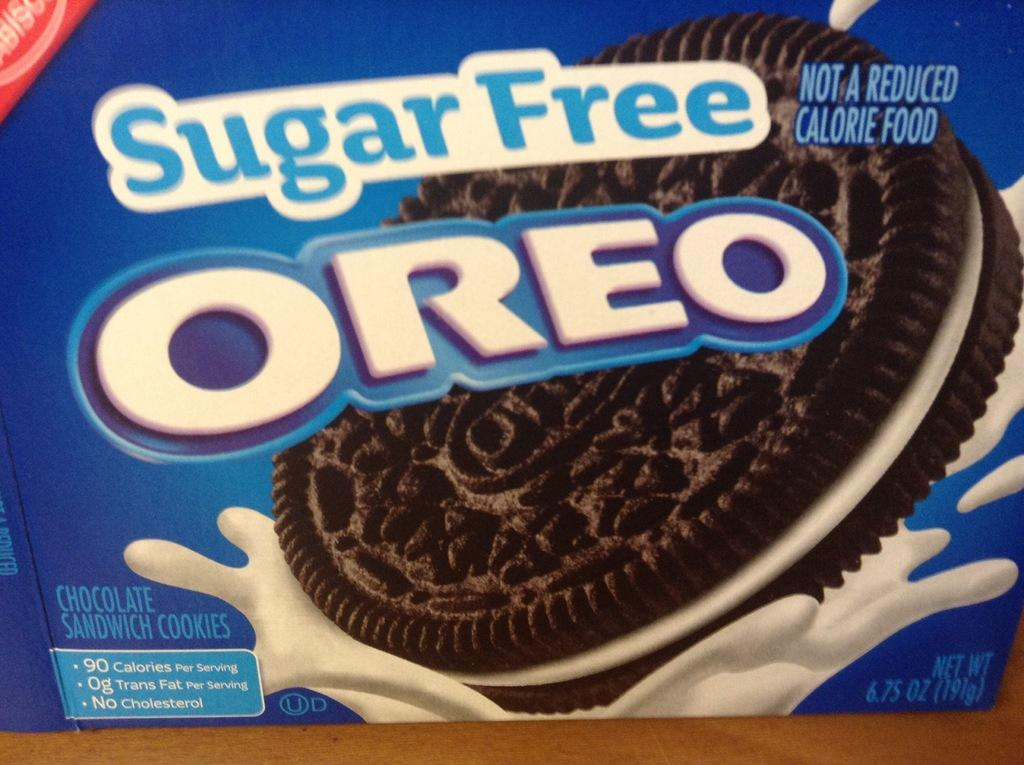What is the main subject of the image? The main subject of the image is an Oreo bucket pack cover. What belief system is represented by the Oreo bucket pack cover in the image? The image does not depict any belief system; it simply features an Oreo bucket pack cover. 